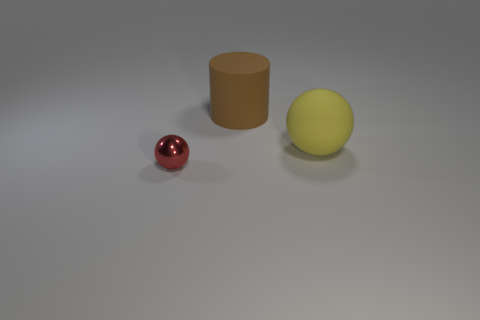Are there any other things that have the same size as the brown cylinder?
Provide a short and direct response. Yes. Is the number of green shiny cylinders greater than the number of matte objects?
Ensure brevity in your answer.  No. There is a rubber thing behind the large thing that is on the right side of the brown rubber object; how big is it?
Ensure brevity in your answer.  Large. There is another object that is the same shape as the large yellow object; what is its color?
Offer a very short reply. Red. What is the size of the brown cylinder?
Provide a succinct answer. Large. How many balls are big brown things or large yellow things?
Provide a succinct answer. 1. There is a red metal object that is the same shape as the yellow object; what size is it?
Provide a succinct answer. Small. What number of gray blocks are there?
Your answer should be very brief. 0. There is a tiny shiny object; does it have the same shape as the big object behind the large sphere?
Keep it short and to the point. No. How big is the rubber object that is in front of the brown cylinder?
Your response must be concise. Large. 